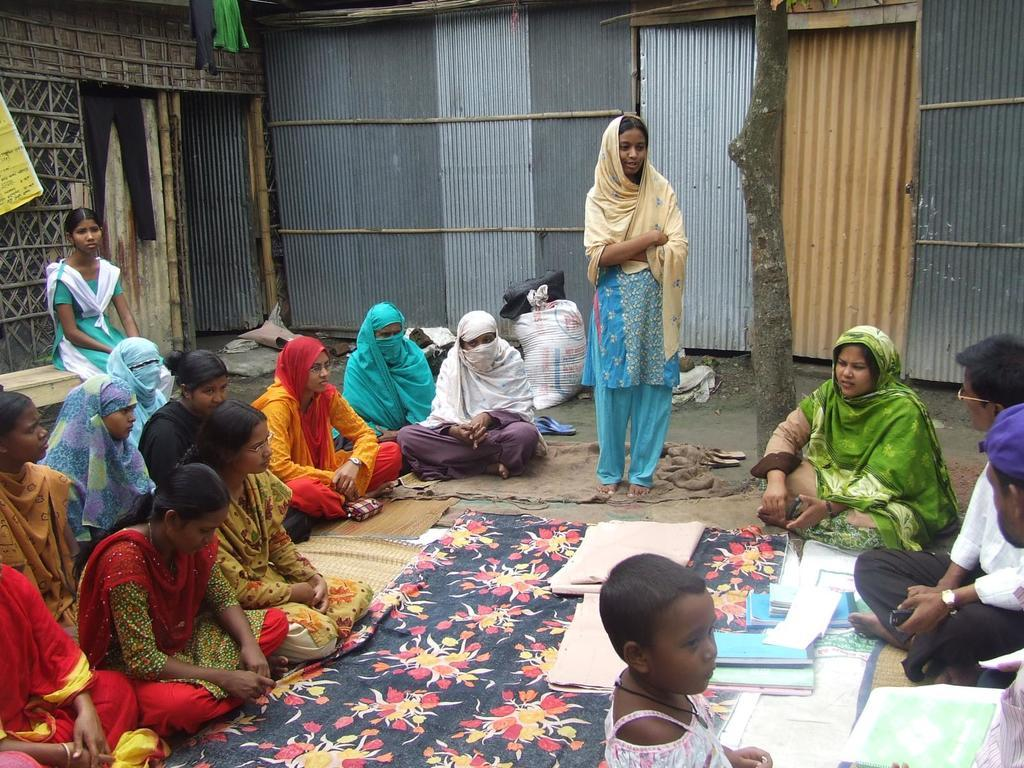What is the girl in the image doing? The girl is standing and speaking in the image. How are the other people in the image positioned? There is a group of people sitting around the girl. What can be seen at the back side of the image? There are iron sheds at the back side of the image. What is in the middle of the image? There are books in the middle of the image. What type of sky is visible in the image? There is no sky visible in the image; it appears to be an indoor setting. How many oranges are present in the image? There are no oranges present in the image. 